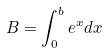Convert formula to latex. <formula><loc_0><loc_0><loc_500><loc_500>B = \int _ { 0 } ^ { b } e ^ { x } d x</formula> 